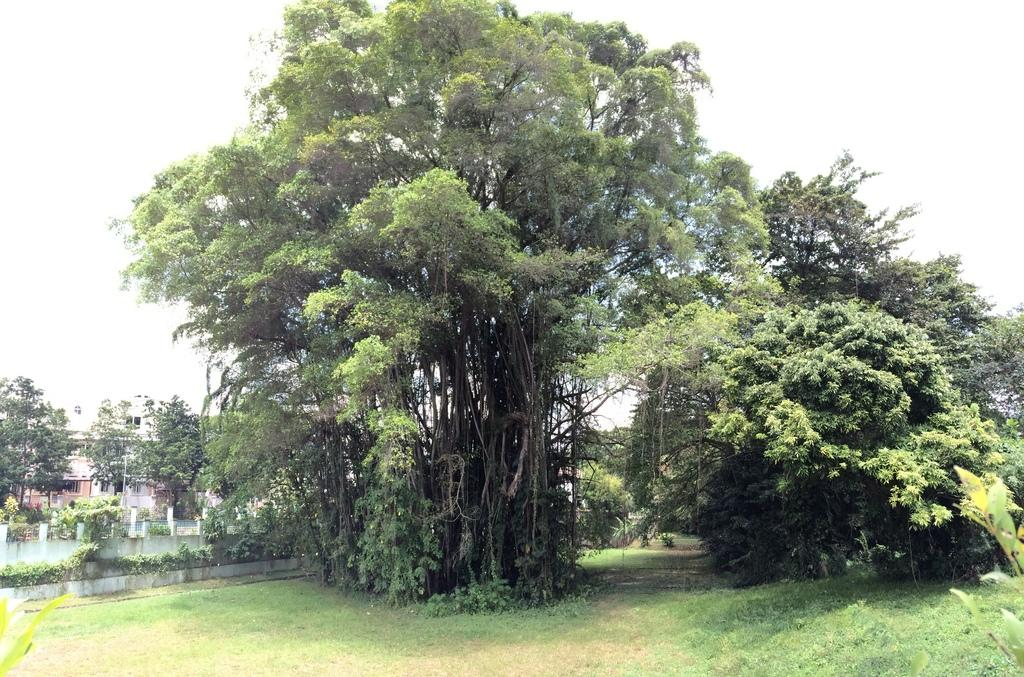What type of vegetation can be seen in the picture? There are trees in the picture. What is at the bottom of the picture? There is green grass at the bottom of the picture. Where is the building located in the picture? There is a building on the left side of the picture. What can be seen in the sky in the picture? There are clouds in the sky. How many quince trees are there in the picture? There is no mention of quince trees in the provided facts, so we cannot determine the number of quince trees in the image. Can you see a scarecrow standing among the trees in the picture? There is no mention of a scarecrow in the provided facts, so we cannot determine if there is a scarecrow in the image. 